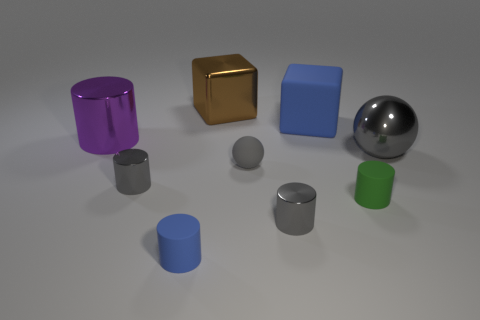What are the different objects displayed in the image? The image shows a collection of 3D rendered objects including a purple cylinder, a gold cube, a big blue cube, a silver sphere, a small grey cylinder, a medium grey cylinder, and a green cylinder. They are presented on a neutral surface and the arrangement suggests a study in geometry and color contrasts. 